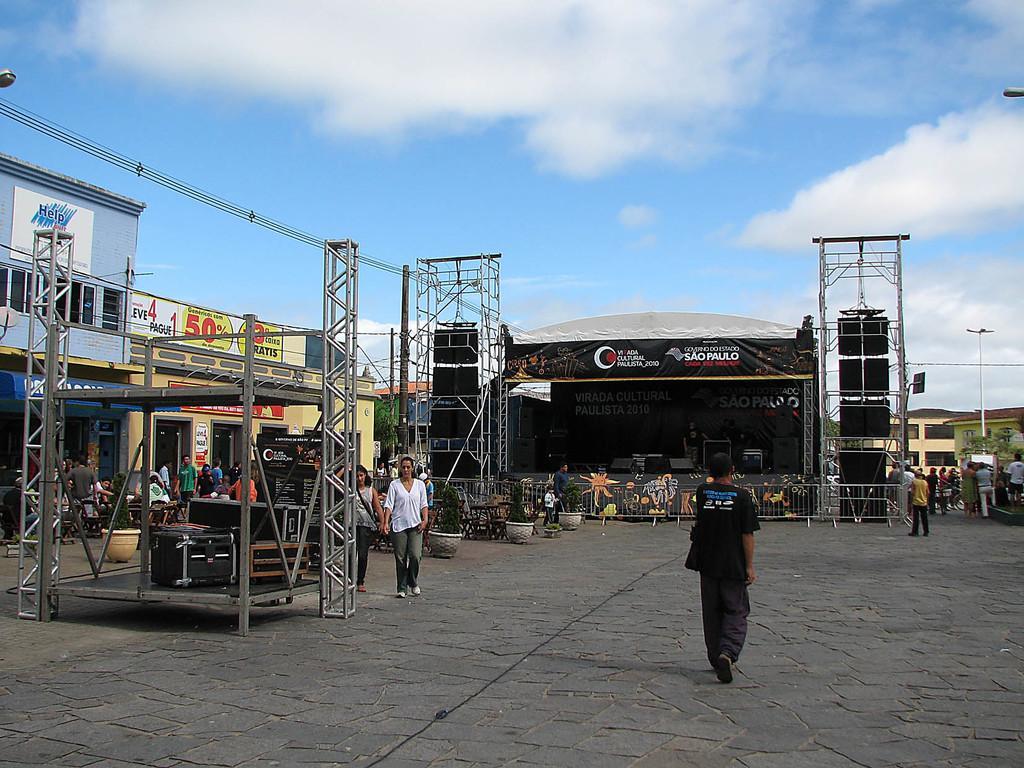Could you give a brief overview of what you see in this image? In this image in the center there are persons standing and walking and there are objects. In the background there are buildings, there are boards with some text and numbers written on it and there are persons standing and walking. There are plants, stands and the sky is cloudy. 